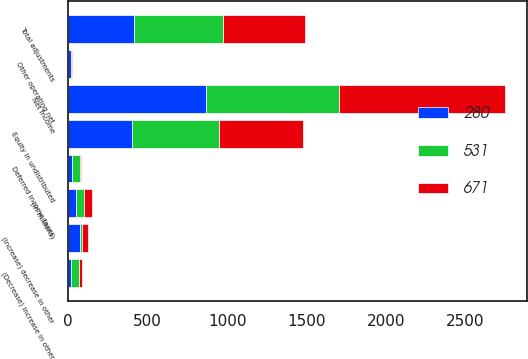Convert chart. <chart><loc_0><loc_0><loc_500><loc_500><stacked_bar_chart><ecel><fcel>(in millions)<fcel>Net income<fcel>Deferred income taxes<fcel>Equity in undistributed<fcel>(Decrease) increase in other<fcel>(Increase) decrease in other<fcel>Other operating net<fcel>Total adjustments<nl><fcel>671<fcel>49<fcel>1045<fcel>5<fcel>526<fcel>19<fcel>35<fcel>4<fcel>512<nl><fcel>531<fcel>49<fcel>840<fcel>49<fcel>546<fcel>48<fcel>16<fcel>3<fcel>561<nl><fcel>280<fcel>49<fcel>865<fcel>27<fcel>404<fcel>18<fcel>74<fcel>17<fcel>416<nl></chart> 